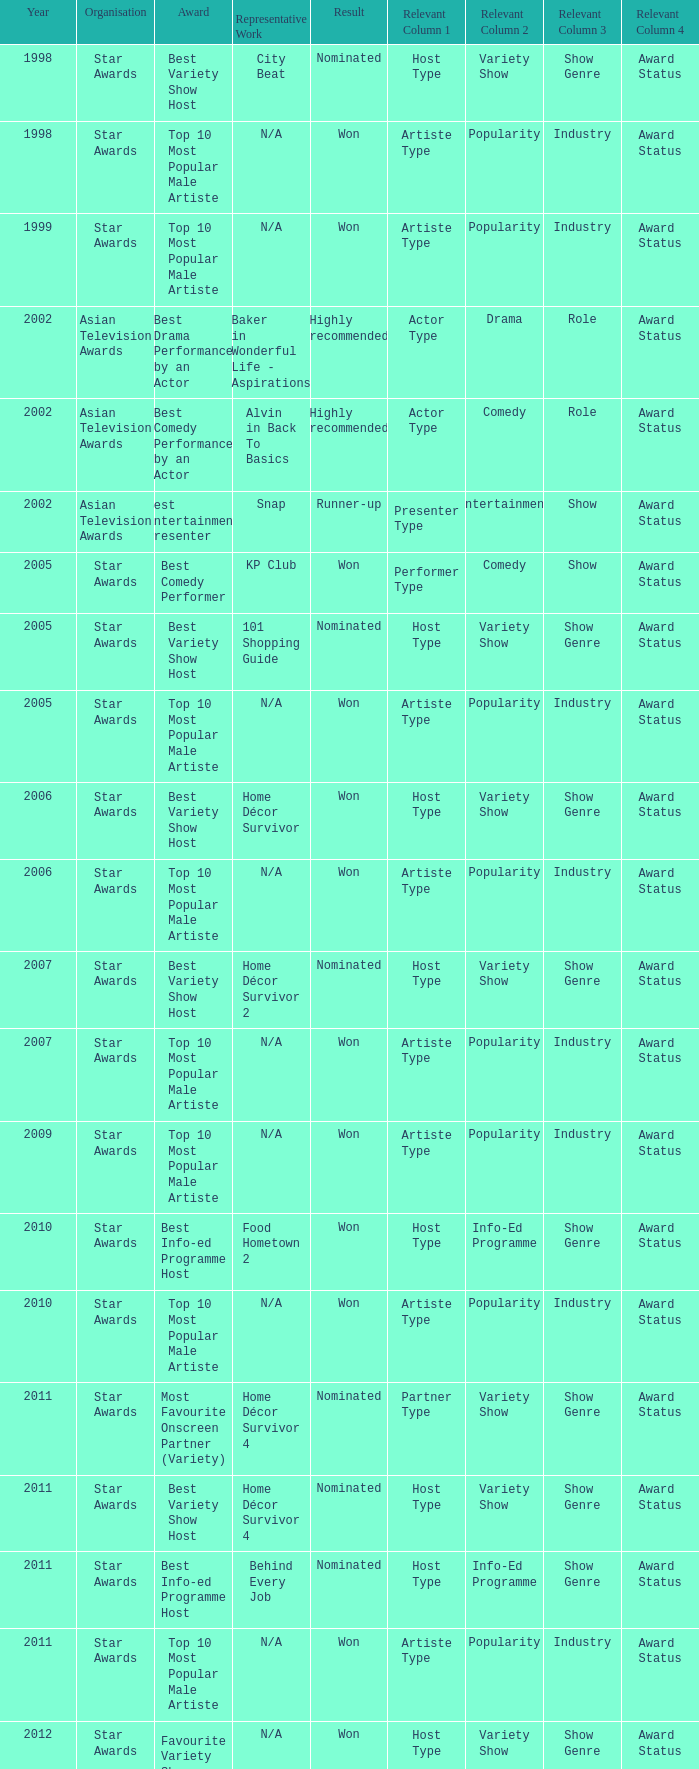Would you mind parsing the complete table? {'header': ['Year', 'Organisation', 'Award', 'Representative Work', 'Result', 'Relevant Column 1', 'Relevant Column 2', 'Relevant Column 3', 'Relevant Column 4'], 'rows': [['1998', 'Star Awards', 'Best Variety Show Host', 'City Beat', 'Nominated', 'Host Type', 'Variety Show', 'Show Genre', 'Award Status'], ['1998', 'Star Awards', 'Top 10 Most Popular Male Artiste', 'N/A', 'Won', 'Artiste Type', 'Popularity', 'Industry', 'Award Status'], ['1999', 'Star Awards', 'Top 10 Most Popular Male Artiste', 'N/A', 'Won', 'Artiste Type', 'Popularity', 'Industry', 'Award Status'], ['2002', 'Asian Television Awards', 'Best Drama Performance by an Actor', 'Baker in Wonderful Life - Aspirations', 'Highly recommended', 'Actor Type', 'Drama', 'Role', 'Award Status'], ['2002', 'Asian Television Awards', 'Best Comedy Performance by an Actor', 'Alvin in Back To Basics', 'Highly recommended', 'Actor Type', 'Comedy', 'Role', 'Award Status'], ['2002', 'Asian Television Awards', 'Best Entertainment Presenter', 'Snap', 'Runner-up', 'Presenter Type', 'Entertainment', 'Show', 'Award Status'], ['2005', 'Star Awards', 'Best Comedy Performer', 'KP Club', 'Won', 'Performer Type', 'Comedy', 'Show', 'Award Status'], ['2005', 'Star Awards', 'Best Variety Show Host', '101 Shopping Guide', 'Nominated', 'Host Type', 'Variety Show', 'Show Genre', 'Award Status'], ['2005', 'Star Awards', 'Top 10 Most Popular Male Artiste', 'N/A', 'Won', 'Artiste Type', 'Popularity', 'Industry', 'Award Status'], ['2006', 'Star Awards', 'Best Variety Show Host', 'Home Décor Survivor', 'Won', 'Host Type', 'Variety Show', 'Show Genre', 'Award Status'], ['2006', 'Star Awards', 'Top 10 Most Popular Male Artiste', 'N/A', 'Won', 'Artiste Type', 'Popularity', 'Industry', 'Award Status'], ['2007', 'Star Awards', 'Best Variety Show Host', 'Home Décor Survivor 2', 'Nominated', 'Host Type', 'Variety Show', 'Show Genre', 'Award Status'], ['2007', 'Star Awards', 'Top 10 Most Popular Male Artiste', 'N/A', 'Won', 'Artiste Type', 'Popularity', 'Industry', 'Award Status'], ['2009', 'Star Awards', 'Top 10 Most Popular Male Artiste', 'N/A', 'Won', 'Artiste Type', 'Popularity', 'Industry', 'Award Status'], ['2010', 'Star Awards', 'Best Info-ed Programme Host', 'Food Hometown 2', 'Won', 'Host Type', 'Info-Ed Programme', 'Show Genre', 'Award Status'], ['2010', 'Star Awards', 'Top 10 Most Popular Male Artiste', 'N/A', 'Won', 'Artiste Type', 'Popularity', 'Industry', 'Award Status'], ['2011', 'Star Awards', 'Most Favourite Onscreen Partner (Variety)', 'Home Décor Survivor 4', 'Nominated', 'Partner Type', 'Variety Show', 'Show Genre', 'Award Status'], ['2011', 'Star Awards', 'Best Variety Show Host', 'Home Décor Survivor 4', 'Nominated', 'Host Type', 'Variety Show', 'Show Genre', 'Award Status'], ['2011', 'Star Awards', 'Best Info-ed Programme Host', 'Behind Every Job', 'Nominated', 'Host Type', 'Info-Ed Programme', 'Show Genre', 'Award Status'], ['2011', 'Star Awards', 'Top 10 Most Popular Male Artiste', 'N/A', 'Won', 'Artiste Type', 'Popularity', 'Industry', 'Award Status'], ['2012', 'Star Awards', 'Favourite Variety Show Host', 'N/A', 'Won', 'Host Type', 'Variety Show', 'Show Genre', 'Award Status'], ['2012', 'Star Awards', 'Best Variety Show Host', 'Rénaissance', 'Nominated', 'Host Type', 'Variety Show', 'Show Genre', 'Award Status'], ['2012', 'Star Awards', 'Best Info-ed Programme Host', 'Behind Every Job 2', 'Nominated', 'Host Type', 'Info-Ed Programme', 'Show Genre', 'Award Status'], ['2012', 'Star Awards', 'Top 10 Most Popular Male Artiste', 'N/A', 'Won', 'Artiste Type', 'Popularity', 'Industry', 'Award Status'], ['2013', 'Star Awards', 'Favourite Variety Show Host', 'S.N.A.P. 熠熠星光总动员', 'Won', 'Host Type', 'Variety Show', 'Show Genre', 'Award Status'], ['2013', 'Star Awards', 'Top 10 Most Popular Male Artiste', 'N/A', 'Won', 'Artiste Type', 'Popularity', 'Industry', 'Award Status'], ['2013', 'Star Awards', 'Best Info-Ed Programme Host', 'Makan Unlimited', 'Nominated', 'Host Type', 'Info-Ed Programme', 'Show Genre', 'Award Status'], ['2013', 'Star Awards', 'Best Variety Show Host', 'Jobs Around The World', 'Nominated', 'Host Type', 'Variety Show', 'Show Genre', 'Award Status']]} What is the award for 1998 with Representative Work of city beat? Best Variety Show Host. 